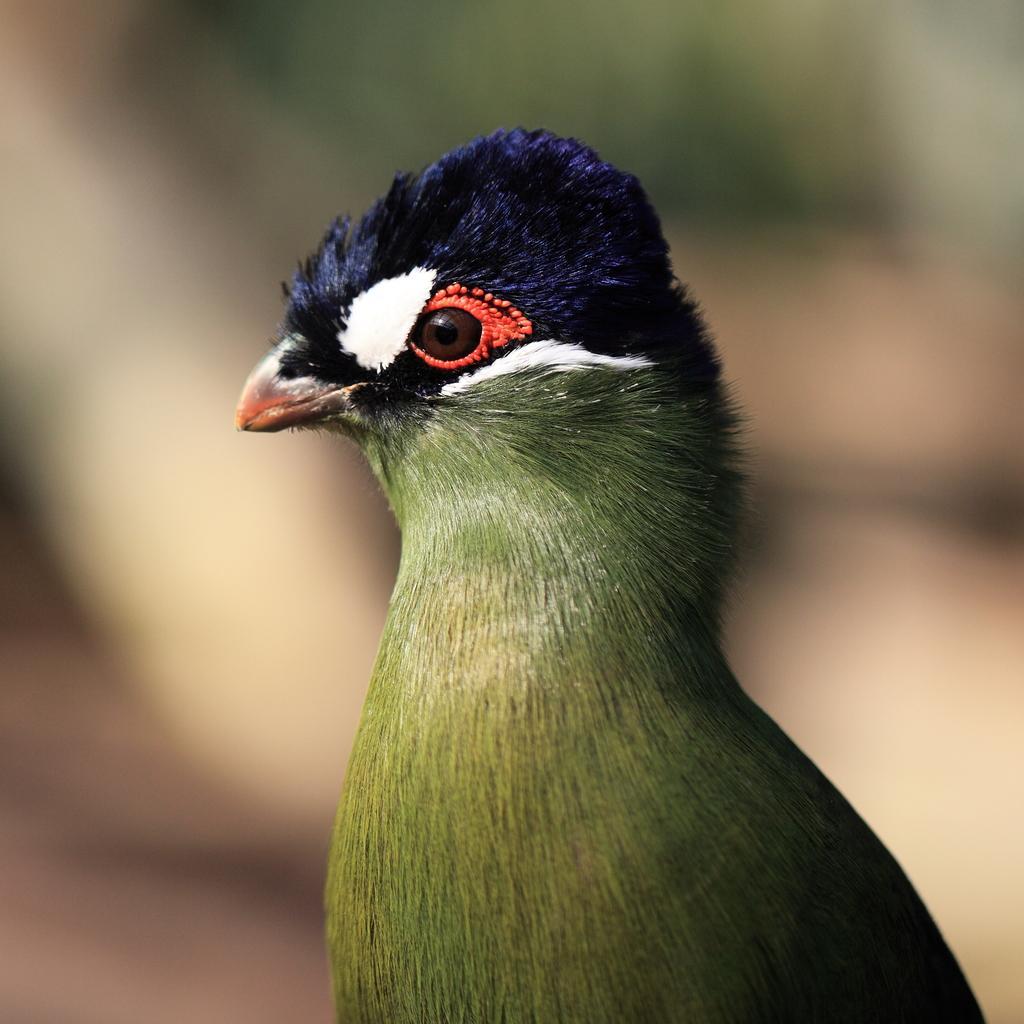Describe this image in one or two sentences. In this image there is a bird. Background is blurry. 